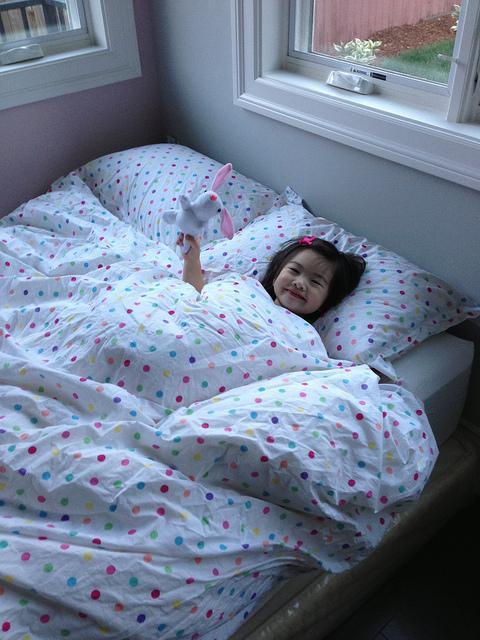How many ski poles?
Give a very brief answer. 0. 